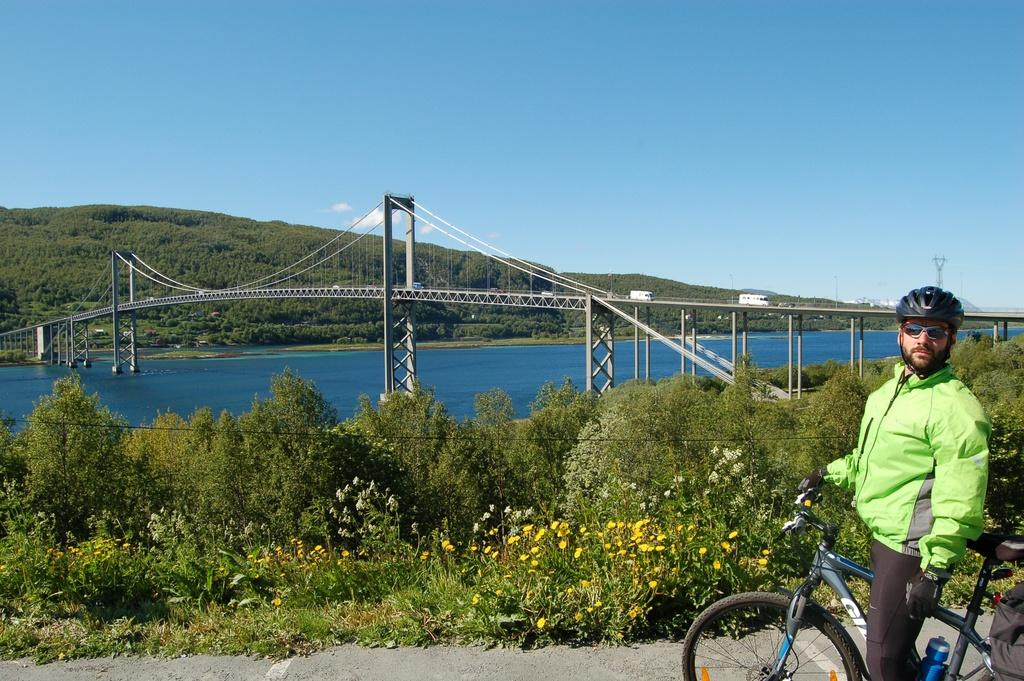What is the man in the image doing? The man is standing in the image while holding a bicycle. What safety equipment is the man wearing? The man is wearing a helmet. What other accessories is the man wearing? The man is wearing glasses and gloves. What type of vegetation can be seen in the image? There are plants, flowers, and trees visible in the image. What can be seen in the background of the image? There is water, vehicles, a bridge, trees, and the sky visible in the background. What type of badge does the police officer have in the image? There is no police officer or badge present in the image. How does the earthquake affect the man and his bicycle in the image? There is no earthquake depicted in the image, so its effects cannot be determined. 